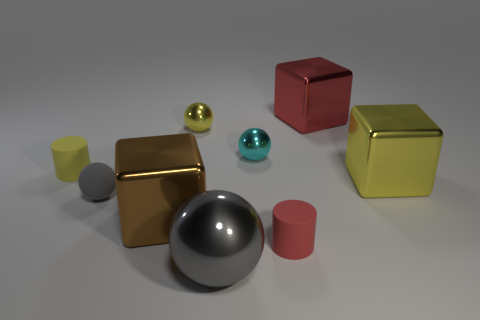What is the color of the other thing that is the same shape as the small yellow rubber thing?
Make the answer very short. Red. Do the sphere that is in front of the brown object and the brown block have the same size?
Provide a succinct answer. Yes. Are there fewer brown things to the left of the cyan shiny thing than big red metallic objects?
Offer a very short reply. No. Is there any other thing that is the same size as the yellow matte cylinder?
Your answer should be compact. Yes. There is a metallic block that is behind the rubber cylinder to the left of the small gray sphere; what size is it?
Make the answer very short. Large. Is there any other thing that is the same shape as the big brown shiny object?
Ensure brevity in your answer.  Yes. Is the number of small gray matte things less than the number of big gray matte cylinders?
Provide a short and direct response. No. There is a big block that is both in front of the large red metallic block and behind the tiny matte ball; what material is it made of?
Your answer should be compact. Metal. There is a small rubber cylinder left of the large gray metal object; is there a cube left of it?
Offer a very short reply. No. What number of objects are either gray matte objects or tiny gray metallic spheres?
Your response must be concise. 1. 